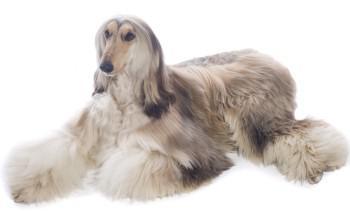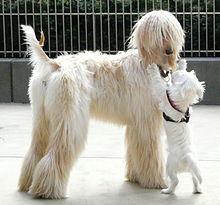The first image is the image on the left, the second image is the image on the right. Considering the images on both sides, is "An image features an afghan hound on green grass." valid? Answer yes or no. No. 